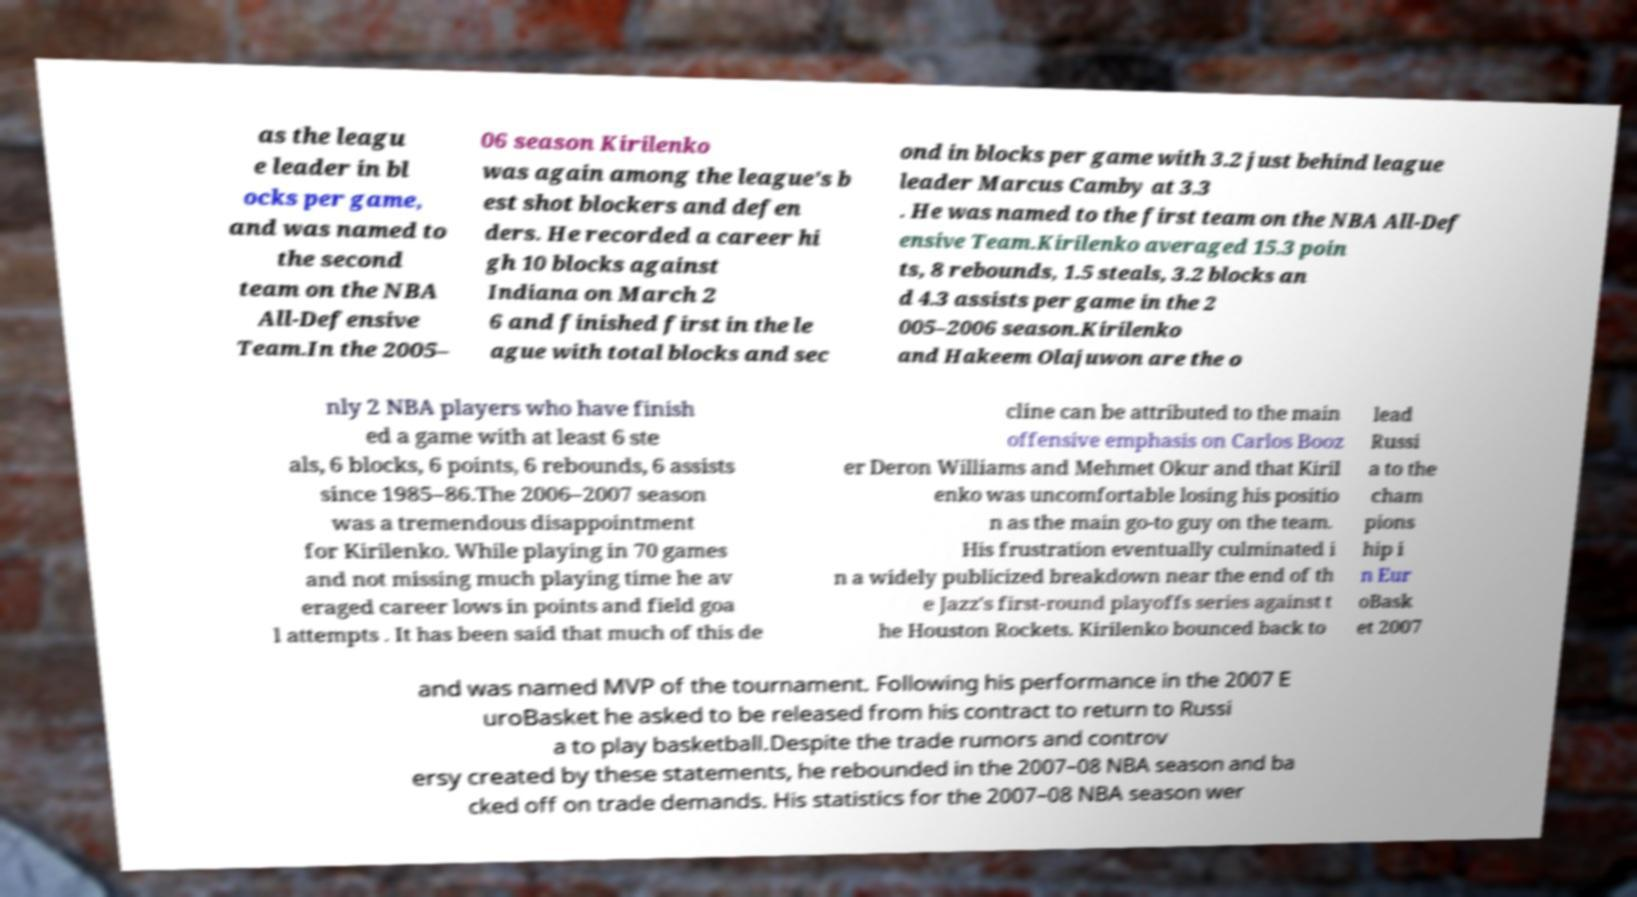I need the written content from this picture converted into text. Can you do that? as the leagu e leader in bl ocks per game, and was named to the second team on the NBA All-Defensive Team.In the 2005– 06 season Kirilenko was again among the league's b est shot blockers and defen ders. He recorded a career hi gh 10 blocks against Indiana on March 2 6 and finished first in the le ague with total blocks and sec ond in blocks per game with 3.2 just behind league leader Marcus Camby at 3.3 . He was named to the first team on the NBA All-Def ensive Team.Kirilenko averaged 15.3 poin ts, 8 rebounds, 1.5 steals, 3.2 blocks an d 4.3 assists per game in the 2 005–2006 season.Kirilenko and Hakeem Olajuwon are the o nly 2 NBA players who have finish ed a game with at least 6 ste als, 6 blocks, 6 points, 6 rebounds, 6 assists since 1985–86.The 2006–2007 season was a tremendous disappointment for Kirilenko. While playing in 70 games and not missing much playing time he av eraged career lows in points and field goa l attempts . It has been said that much of this de cline can be attributed to the main offensive emphasis on Carlos Booz er Deron Williams and Mehmet Okur and that Kiril enko was uncomfortable losing his positio n as the main go-to guy on the team. His frustration eventually culminated i n a widely publicized breakdown near the end of th e Jazz's first-round playoffs series against t he Houston Rockets. Kirilenko bounced back to lead Russi a to the cham pions hip i n Eur oBask et 2007 and was named MVP of the tournament. Following his performance in the 2007 E uroBasket he asked to be released from his contract to return to Russi a to play basketball.Despite the trade rumors and controv ersy created by these statements, he rebounded in the 2007–08 NBA season and ba cked off on trade demands. His statistics for the 2007–08 NBA season wer 